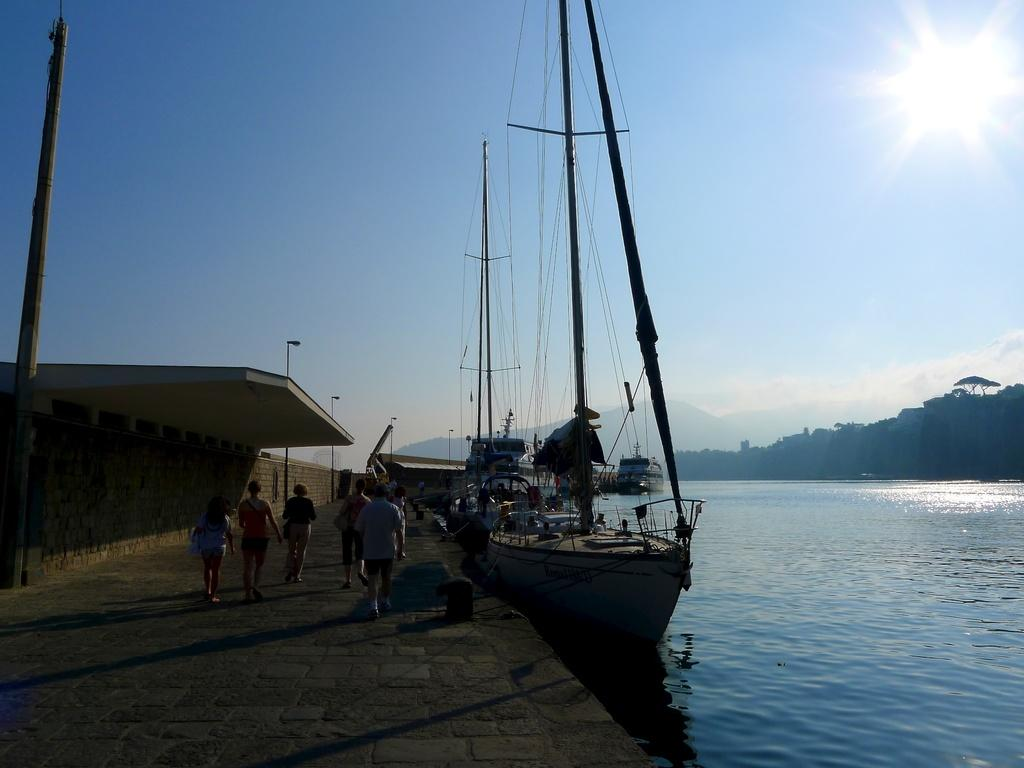What are the people in the image doing? The people in the image are walking on a pavement. What can be seen near the pavement? Ships are present on a river beside the pavement. What is visible in the background of the image? There are trees, a mountain, and the sky visible in the background. What is the sister of the person walking on the pavement doing in the image? There is no mention of a sister in the image, so it cannot be determined what the sister might be doing. 